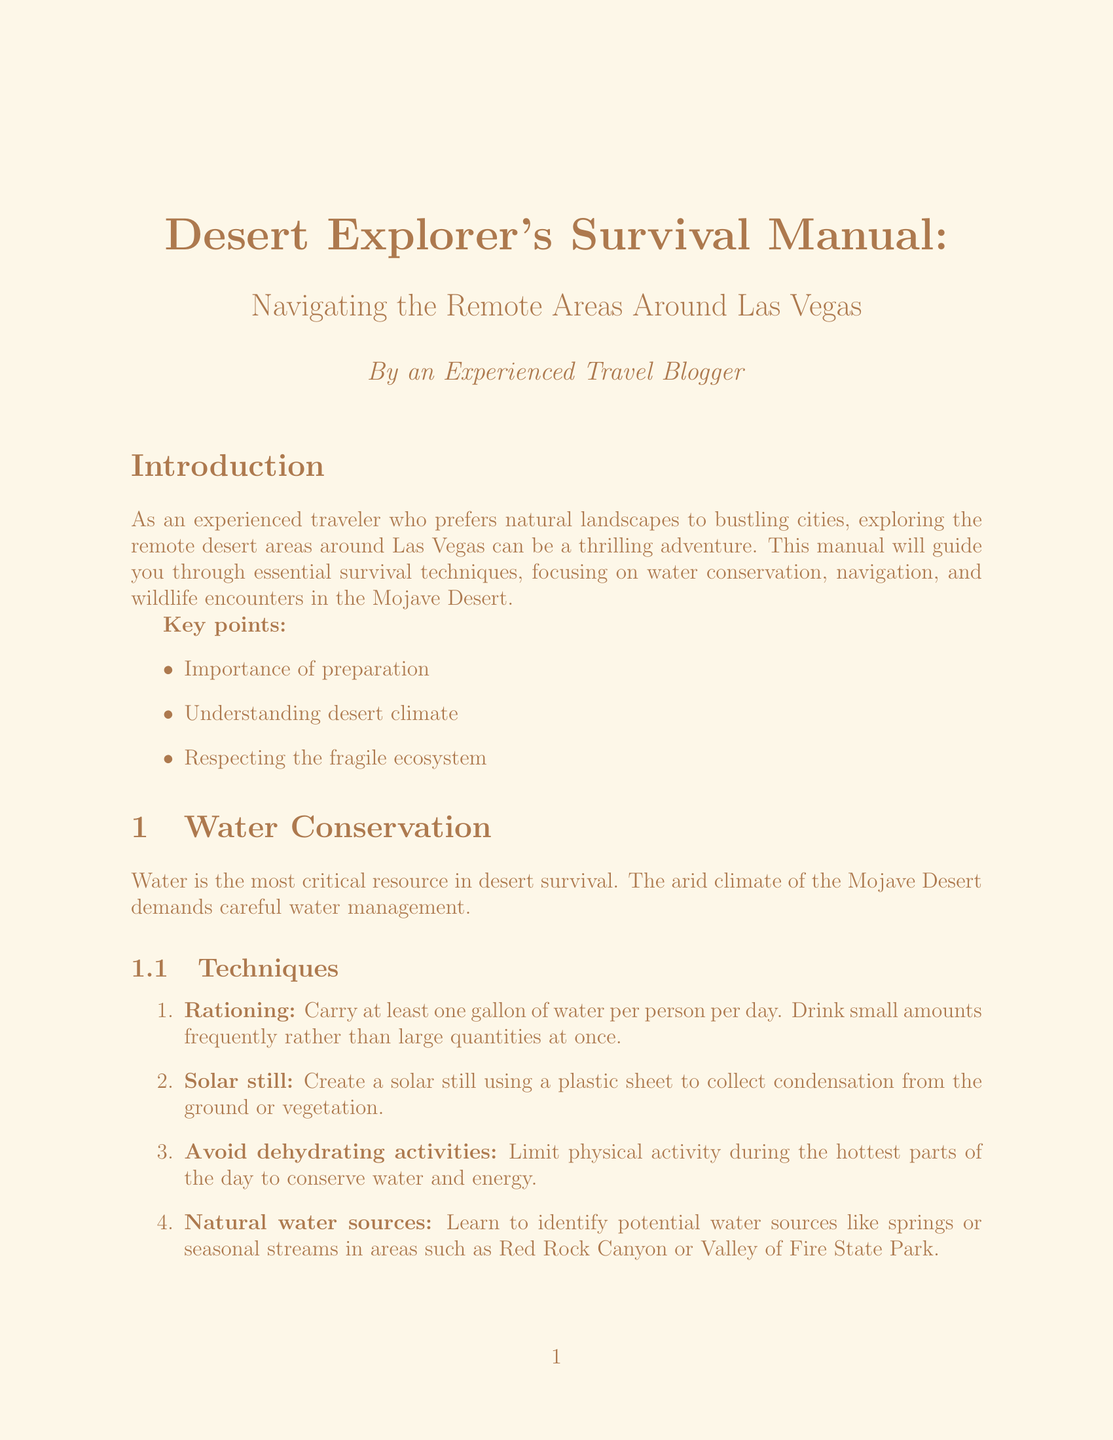what is the title of the manual? The title is given at the beginning of the document and focuses on desert exploration around Las Vegas.
Answer: Desert Explorer's Survival Manual: Navigating the Remote Areas Around Las Vegas what is the primary focus of the manual? The introduction states that the manual will guide you through essential survival techniques.
Answer: Survival techniques how much water should you carry per person per day? The document specifies a recommended amount of water for desert survival.
Answer: One gallon which species is described as typically shy in the Mojave Desert? The wildlife section details behaviors of different species in the area.
Answer: Desert bighorn sheep what tool should you always carry for navigation? The navigation section emphasizes the importance of certain tools for desert exploration.
Answer: GPS device what common wildlife might you encounter that can be venomous? The wildlife section mentions dangers associated with certain animals in the desert.
Answer: Mojave rattlesnake how should you signal for help in case of an emergency? Emergency procedures include signaling methods for attracting attention in the desert.
Answer: Large, contrasting colors or smoke what is a key safety tip while hiking in the desert? The safety tips in the wildlife encounters section emphasize precautions during your hikes.
Answer: Make noise while hiking what is one technique for water conservation mentioned in the manual? The water conservation section covers several techniques for managing water in the desert.
Answer: Rationing 